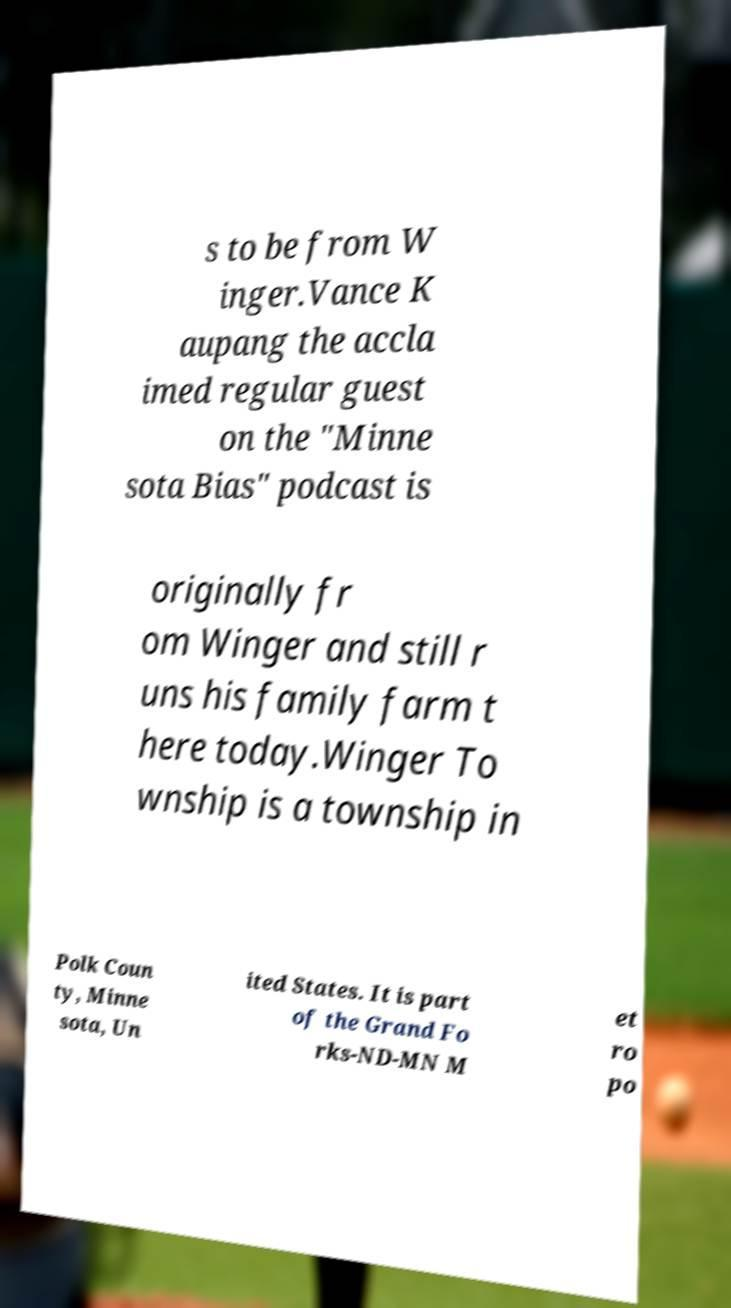Can you read and provide the text displayed in the image?This photo seems to have some interesting text. Can you extract and type it out for me? s to be from W inger.Vance K aupang the accla imed regular guest on the "Minne sota Bias" podcast is originally fr om Winger and still r uns his family farm t here today.Winger To wnship is a township in Polk Coun ty, Minne sota, Un ited States. It is part of the Grand Fo rks-ND-MN M et ro po 